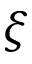<formula> <loc_0><loc_0><loc_500><loc_500>\xi</formula> 